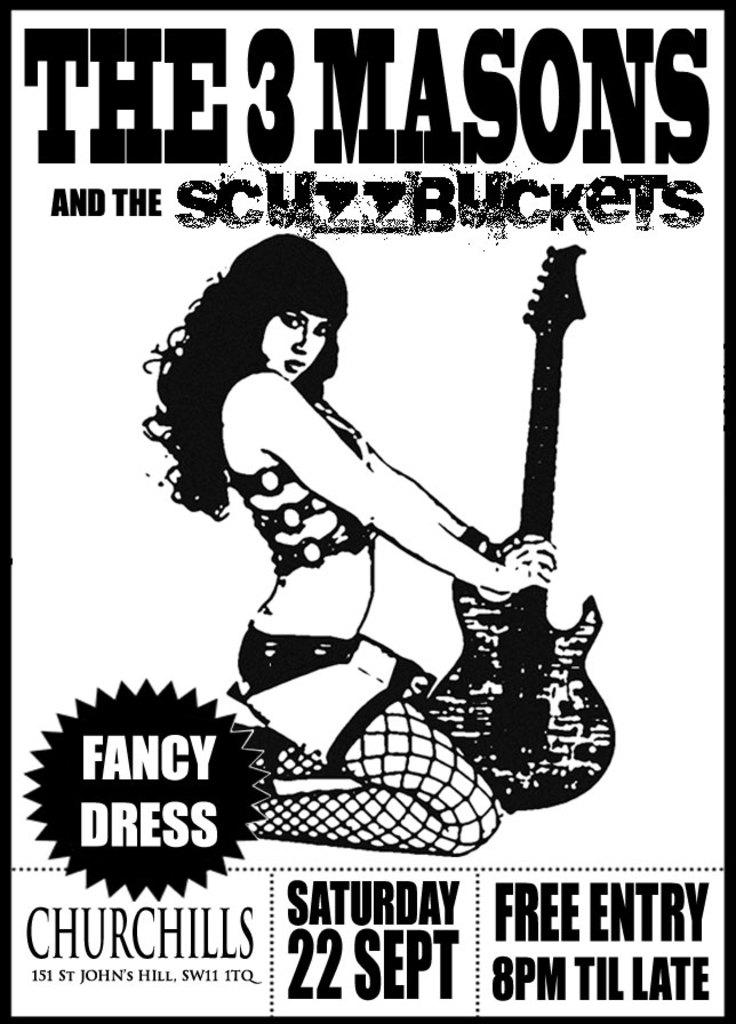<image>
Share a concise interpretation of the image provided. a lady next to a guitar and above saturday 22 sept text 